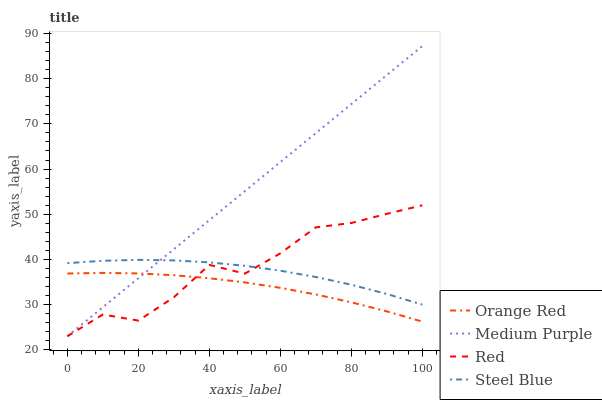Does Orange Red have the minimum area under the curve?
Answer yes or no. Yes. Does Medium Purple have the maximum area under the curve?
Answer yes or no. Yes. Does Red have the minimum area under the curve?
Answer yes or no. No. Does Red have the maximum area under the curve?
Answer yes or no. No. Is Medium Purple the smoothest?
Answer yes or no. Yes. Is Red the roughest?
Answer yes or no. Yes. Is Orange Red the smoothest?
Answer yes or no. No. Is Orange Red the roughest?
Answer yes or no. No. Does Medium Purple have the lowest value?
Answer yes or no. Yes. Does Orange Red have the lowest value?
Answer yes or no. No. Does Medium Purple have the highest value?
Answer yes or no. Yes. Does Red have the highest value?
Answer yes or no. No. Is Orange Red less than Steel Blue?
Answer yes or no. Yes. Is Steel Blue greater than Orange Red?
Answer yes or no. Yes. Does Orange Red intersect Red?
Answer yes or no. Yes. Is Orange Red less than Red?
Answer yes or no. No. Is Orange Red greater than Red?
Answer yes or no. No. Does Orange Red intersect Steel Blue?
Answer yes or no. No. 